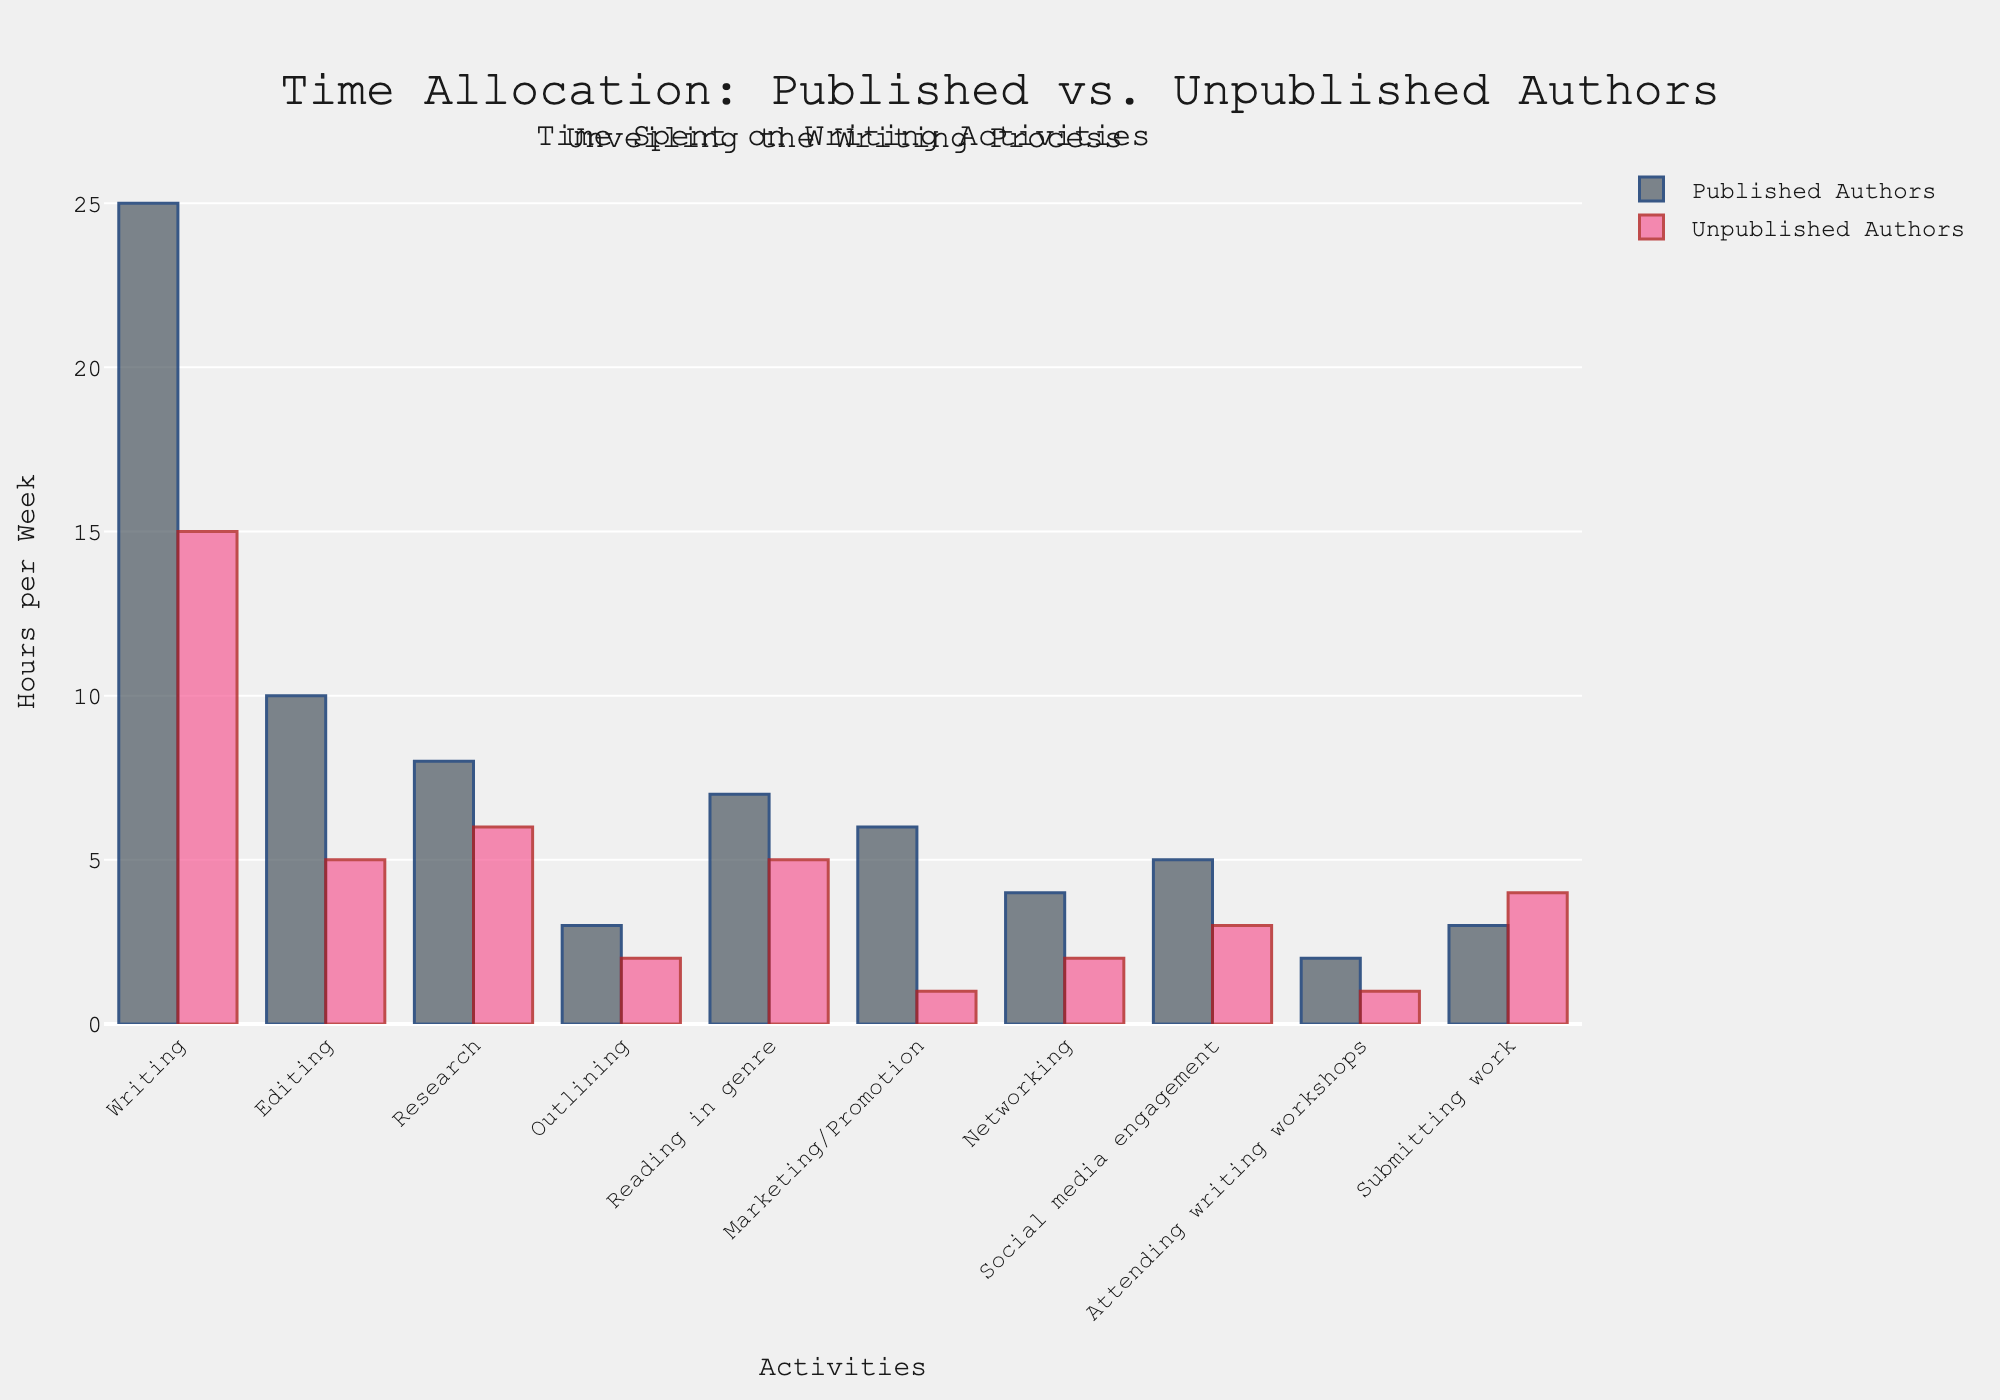Which activity do published authors spend the most time on, and how much? By examining the height of the bars, the tallest bar for published authors is in the writing activity section. The corresponding height indicates they spend 25 hours per week on writing.
Answer: Writing, 25 hours In which activity is the difference in time spent per week the largest between published and unpublished authors? To identify the largest difference, subtract the hours spent by unpublished authors from the hours spent by published authors for each activity. Writing (25-15=10), Editing (10-5=5), Research (8-6=2), Outlining (3-2=1), Reading in genre (7-5=2), Marketing/Promotion (6-1=5), Networking (4-2=2), Social media engagement (5-3=2), Attending writing workshops (2-1=1), Submitting work (3-4=-1). The largest difference is in Writing with a difference of 10 hours.
Answer: Writing, 10 hours What is the total time spent on research and editing combined for published authors? Add the time spent on research (8 hours) and editing (10 hours) for published authors. 8 + 10 = 18 hours.
Answer: 18 hours For which activities do published authors spend twice as much time as unpublished authors? Divide the hours spent by published authors for each activity by the hours spent by unpublished authors. Writing (25/15=1.67), Editing (10/5=2), Research (8/6=1.33), Outlining (3/2=1.5), Reading in genre (7/5=1.4), Marketing/Promotion (6/1=6), Networking (4/2=2), Social media engagement (5/3=1.67), Attending writing workshops (2/1=2), Submitting work (3/4=0.75). Activities where the ratio is exactly 2 are Editing, Networking, and Attending writing workshops.
Answer: Editing, Networking, Attending writing workshops Do published authors spend more time on social media engagement or on marketing/promotion? By comparing the heights of the bars for social media engagement and marketing/promotion for published authors, the social media engagement bar corresponds to 5 hours and the marketing/promotion bar corresponds to 6 hours. Marketing/promotion is higher.
Answer: Marketing/Promotion How many total hours per week do unpublished authors spend on writing, editing, and researching combined? Add the hours spent on writing (15 hours), editing (5 hours), and research (6 hours) for unpublished authors. 15 + 5 + 6 = 26 hours.
Answer: 26 hours Which group spends more time on submitting work, and by how much? Compare the bars for submitting work. Published authors spend 3 hours, and unpublished authors spend 4 hours. Unpublished authors spend 1 more hour.
Answer: Unpublished authors, 1 hour What is the average time spent by published authors on outlining, networking, and attending writing workshops? Add the hours spent on outlining (3 hours), networking (4 hours), and attending writing workshops (2 hours) for published authors, and then divide by the number of activities (3). (3 + 4 + 2) / 3 ≈ 3 hours.
Answer: 3 hours 